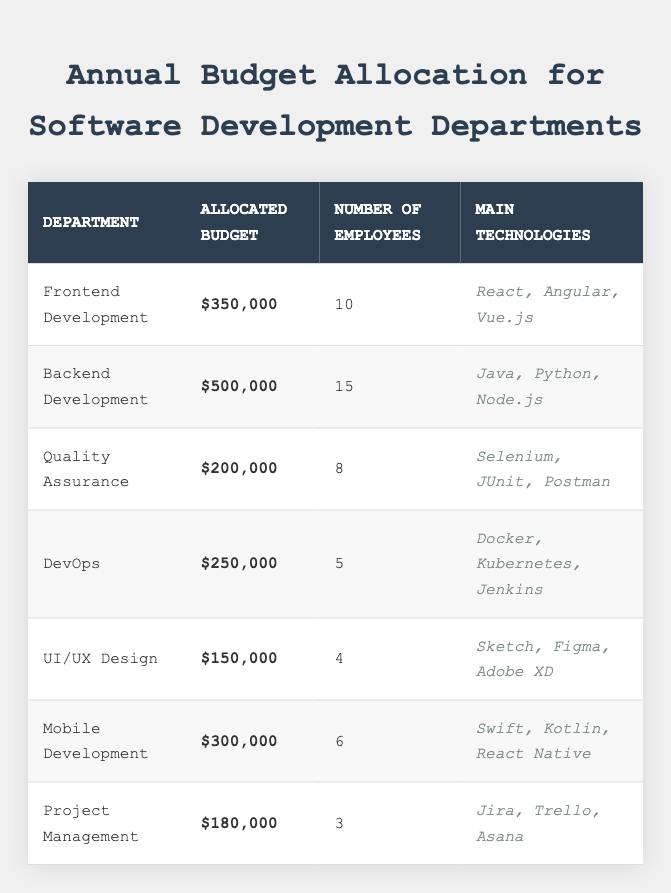What is the allocated budget for the Backend Development department? The table lists the allocated budget for each department, and for Backend Development, the allocated budget is shown as $500,000.
Answer: $500,000 How many employees work in the Frontend Development department? Referring to the table, the number of employees in the Frontend Development department is stated as 10.
Answer: 10 Which department has the highest allocated budget? By comparing the allocated budgets in the table, Backend Development has the highest budget of $500,000.
Answer: Backend Development What is the total number of employees across all departments? The total number of employees can be found by adding the employees from each department: 10 (Frontend) + 15 (Backend) + 8 (Quality Assurance) + 5 (DevOps) + 4 (UI/UX Design) + 6 (Mobile Development) + 3 (Project Management) = 51.
Answer: 51 What is the allocated budget for UI/UX Design and Mobile Development combined? The allocated budgets for UI/UX Design and Mobile Development are $150,000 and $300,000 respectively. Adding these together gives: 150,000 + 300,000 = $450,000.
Answer: $450,000 Does the Quality Assurance department have a higher allocated budget than the UI/UX Design department? The allocated budget for Quality Assurance is $200,000 which is greater than the $150,000 allocated to UI/UX Design; thus, the statement is true.
Answer: Yes What percentage of the total budget is allocated to the DevOps department? First, calculate the total budget: $350,000 + $500,000 + $200,000 + $250,000 + $150,000 + $300,000 + $180,000 = $1,930,000. The budget for DevOps is $250,000. The percentage allocated is (250,000 / 1,930,000) * 100 ≈ 12.95%.
Answer: Approximately 12.95% What is the difference in allocated budget between the Backend and Frontend Development departments? The allocated budget for Backend Development is $500,000 and for Frontend Development, it is $350,000. The difference is calculated as: 500,000 - 350,000 = $150,000.
Answer: $150,000 Which technologies are used by the Mobile Development department? Looking at the table, the main technologies listed for the Mobile Development department are Swift, Kotlin, and React Native.
Answer: Swift, Kotlin, React Native What is the average allocated budget per employee for the Quality Assurance department? The allocated budget for Quality Assurance is $200,000, and there are 8 employees. The average allocated budget per employee is calculated as: 200,000 / 8 = $25,000.
Answer: $25,000 